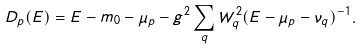<formula> <loc_0><loc_0><loc_500><loc_500>D _ { p } ( E ) = E - m _ { 0 } - \mu _ { p } - g ^ { 2 } \sum _ { q } W _ { q } ^ { 2 } ( E - \mu _ { p } - \nu _ { q } ) ^ { - 1 } .</formula> 